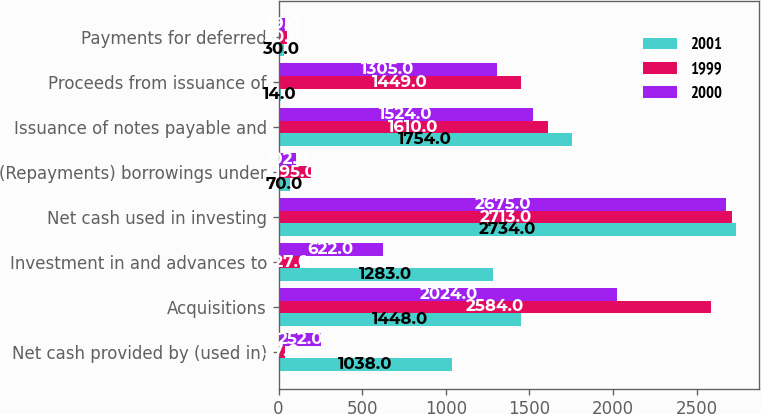Convert chart. <chart><loc_0><loc_0><loc_500><loc_500><stacked_bar_chart><ecel><fcel>Net cash provided by (used in)<fcel>Acquisitions<fcel>Investment in and advances to<fcel>Net cash used in investing<fcel>(Repayments) borrowings under<fcel>Issuance of notes payable and<fcel>Proceeds from issuance of<fcel>Payments for deferred<nl><fcel>2001<fcel>1038<fcel>1448<fcel>1283<fcel>2734<fcel>70<fcel>1754<fcel>14<fcel>30<nl><fcel>1999<fcel>37<fcel>2584<fcel>127<fcel>2713<fcel>195<fcel>1610<fcel>1449<fcel>50<nl><fcel>2000<fcel>252<fcel>2024<fcel>622<fcel>2675<fcel>102<fcel>1524<fcel>1305<fcel>39<nl></chart> 